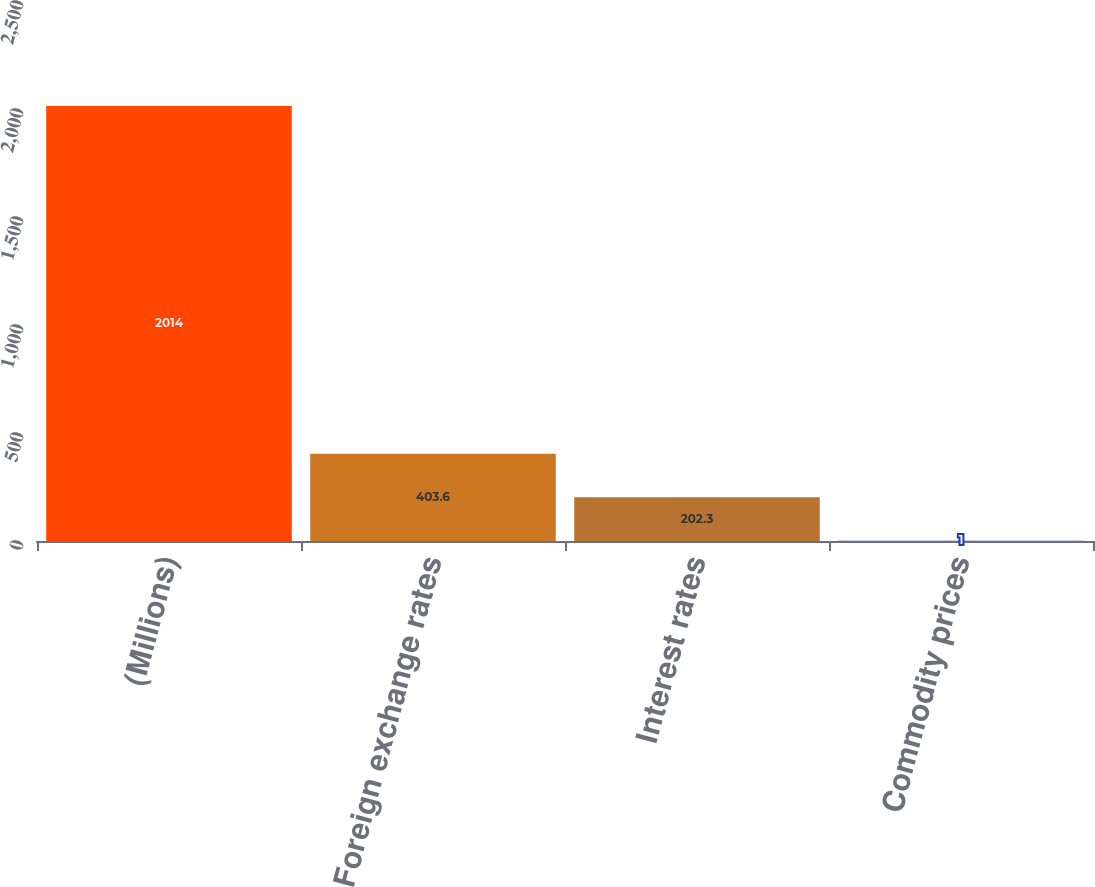Convert chart. <chart><loc_0><loc_0><loc_500><loc_500><bar_chart><fcel>(Millions)<fcel>Foreign exchange rates<fcel>Interest rates<fcel>Commodity prices<nl><fcel>2014<fcel>403.6<fcel>202.3<fcel>1<nl></chart> 